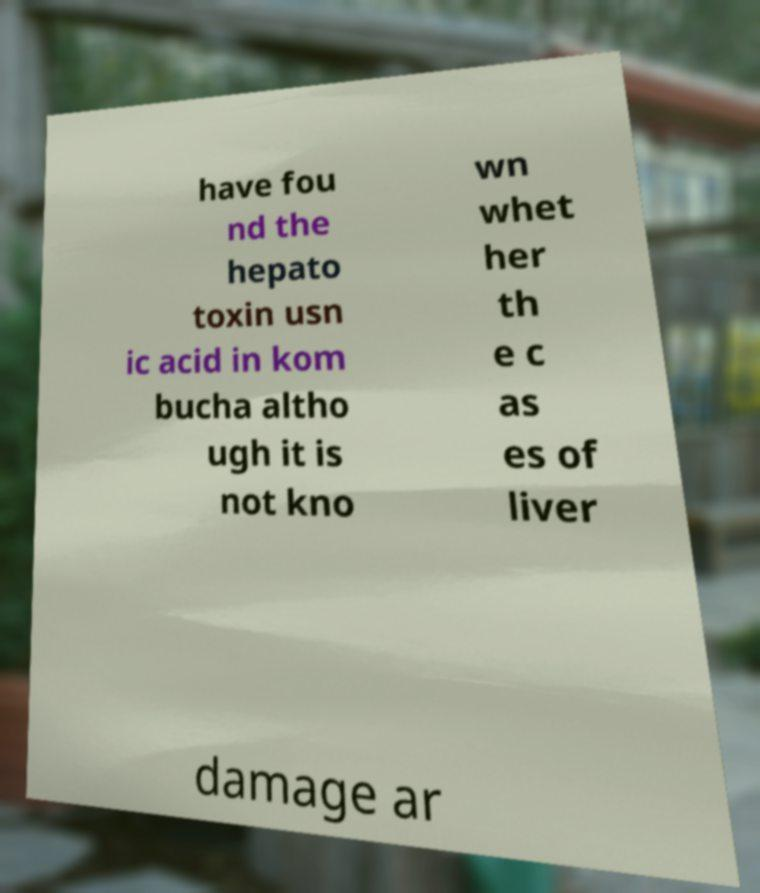Can you read and provide the text displayed in the image?This photo seems to have some interesting text. Can you extract and type it out for me? have fou nd the hepato toxin usn ic acid in kom bucha altho ugh it is not kno wn whet her th e c as es of liver damage ar 